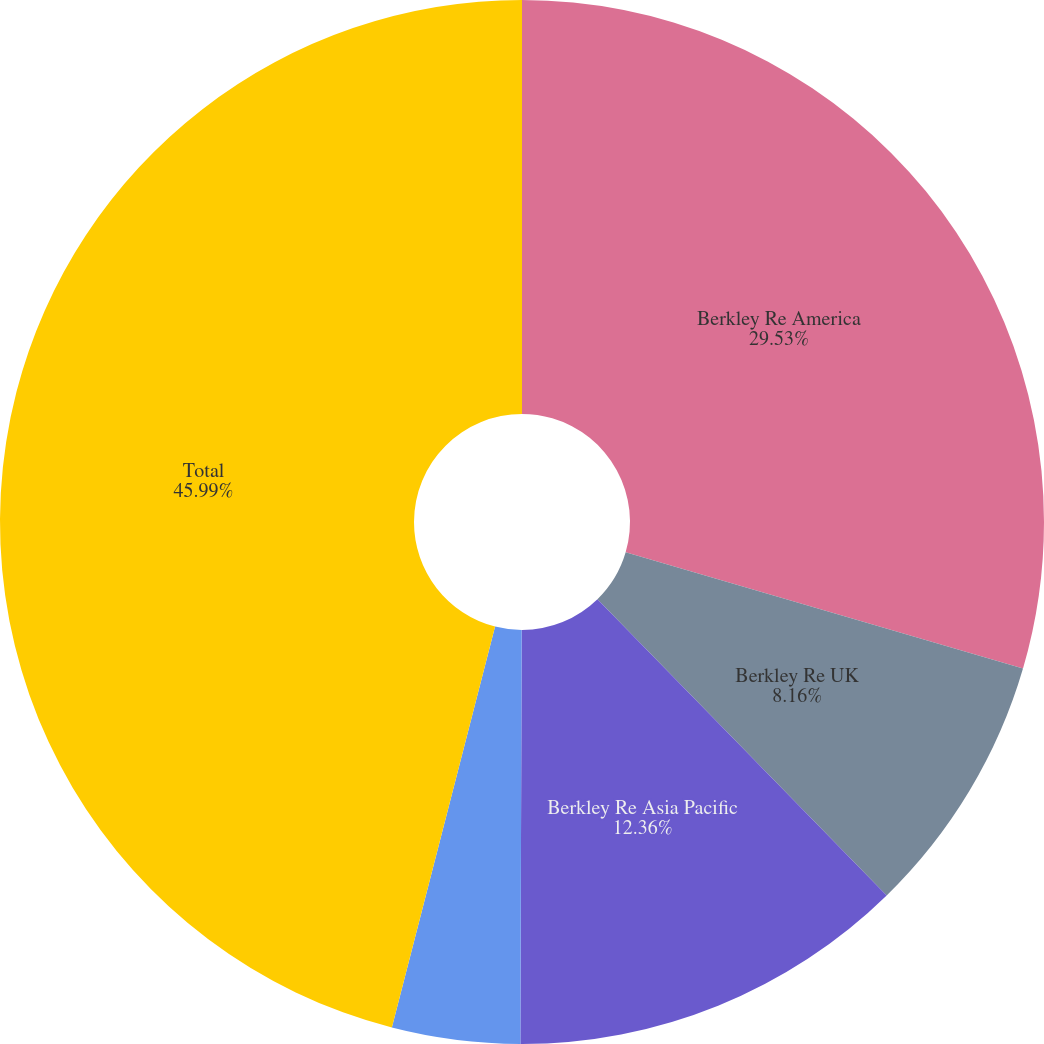Convert chart to OTSL. <chart><loc_0><loc_0><loc_500><loc_500><pie_chart><fcel>Berkley Re America<fcel>Berkley Re UK<fcel>Berkley Re Asia Pacific<fcel>Berkley Re Direct<fcel>Total<nl><fcel>29.53%<fcel>8.16%<fcel>12.36%<fcel>3.96%<fcel>45.99%<nl></chart> 